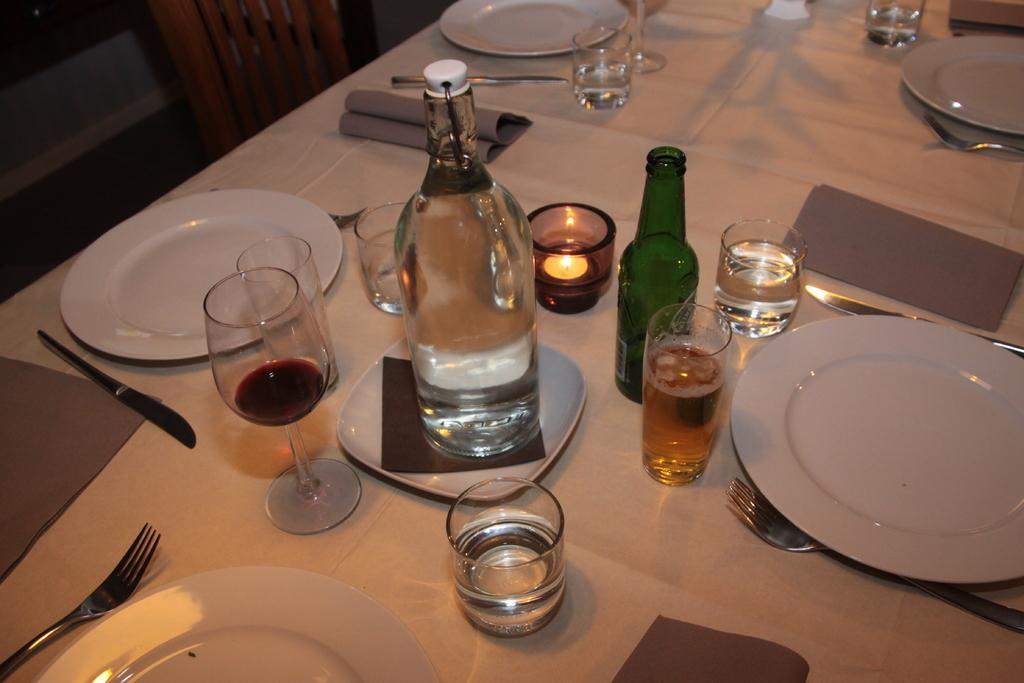How many plates are on the table in the image? There are five plates on the table. What else can be seen on the table besides plates? There are wine bottles, glasses, a glass with a candle, and forks and knives on the table. What is the purpose of the glass with the candle? The glass with the candle is likely used for decoration or ambiance. What type of utensils are on the table? There are forks and knives on the table. Is there any seating visible in the image? Yes, there is a chair in the image. What new idea is being discussed at the recess in the image? There is no recess or discussion present in the image; it is a still image of a table setting. 